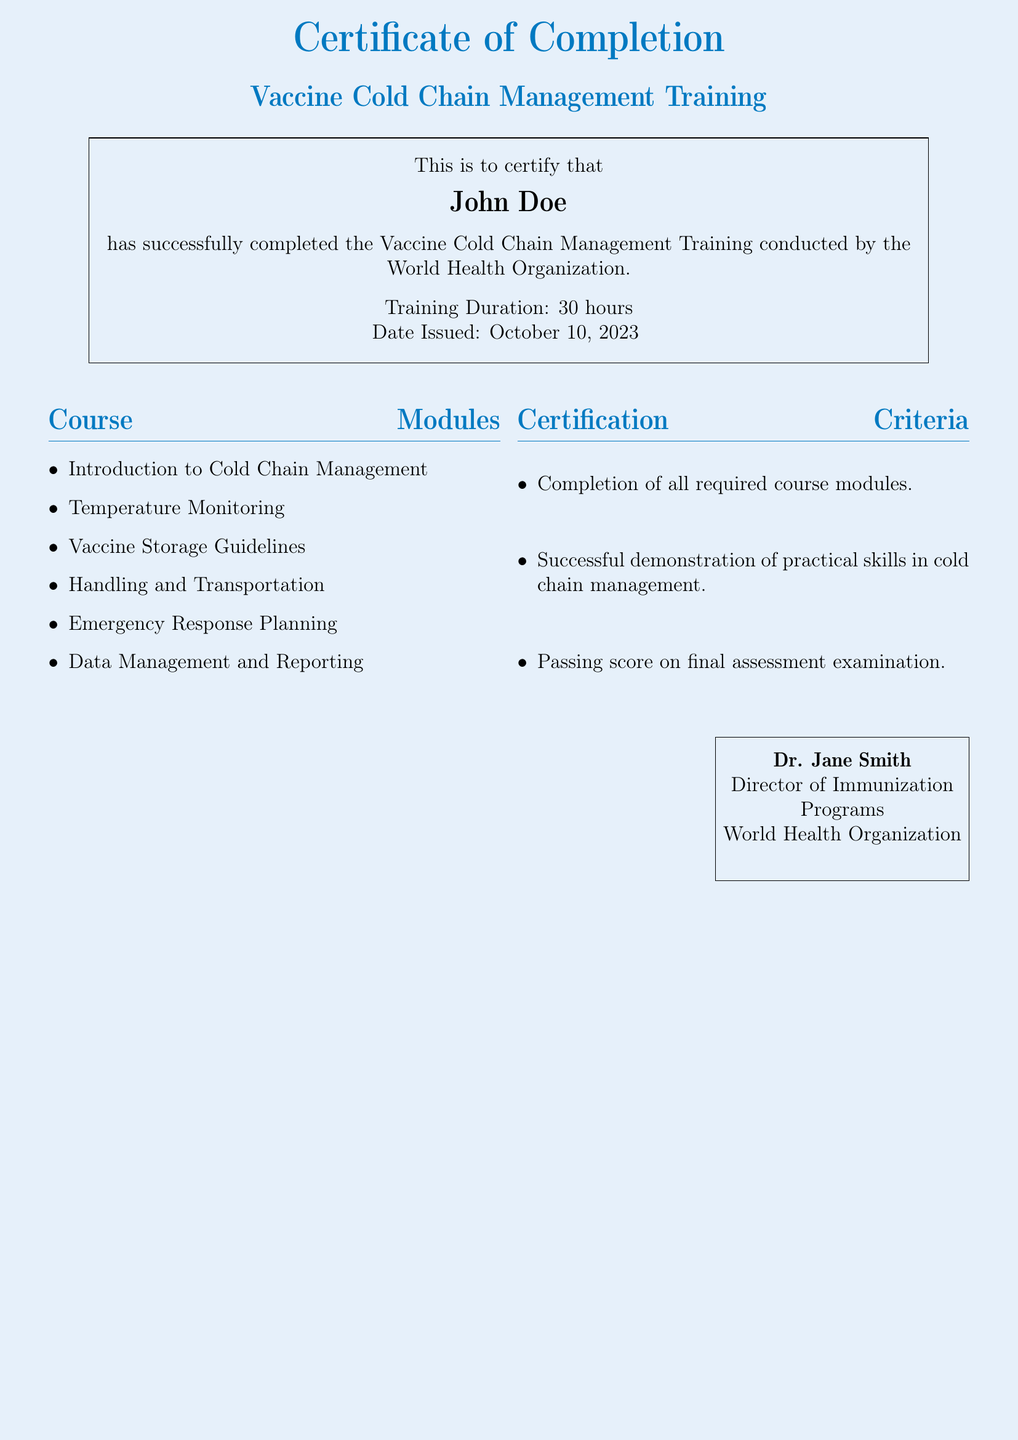What is the title of the training? The title of the training is clearly stated in the document as "Vaccine Cold Chain Management Training."
Answer: Vaccine Cold Chain Management Training Who completed the training? The name of the individual who completed the training is mentioned in the certificate.
Answer: John Doe What is the duration of the training? The duration of the training is specified in the document as "30 hours."
Answer: 30 hours On what date was the certificate issued? The document states the date on which the certificate was issued.
Answer: October 10, 2023 Who is the Director of Immunization Programs? The document provides the name of the person in this position.
Answer: Dr. Jane Smith What is one of the certification criteria? A specific criterion for certification is mentioned in the document, and one of them is "Completion of all required course modules."
Answer: Completion of all required course modules How many modules are listed in the Course Modules section? The number of modules can be counted from the list provided in the document.
Answer: Six What is the color theme of the document? The color theme is part of the design elements mentioned in the document.
Answer: WHO blue and light blue What is a key topic covered in the training modules? A key topic is highlighted in the list of course modules.
Answer: Temperature Monitoring 